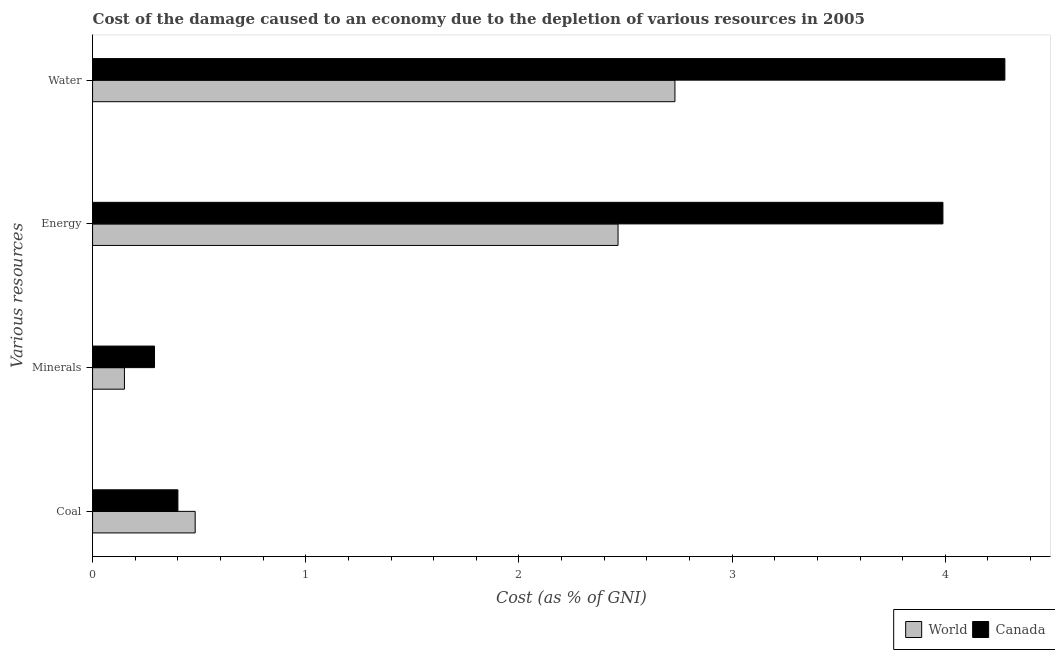How many groups of bars are there?
Keep it short and to the point. 4. Are the number of bars per tick equal to the number of legend labels?
Give a very brief answer. Yes. How many bars are there on the 1st tick from the bottom?
Keep it short and to the point. 2. What is the label of the 3rd group of bars from the top?
Give a very brief answer. Minerals. What is the cost of damage due to depletion of coal in World?
Your answer should be compact. 0.48. Across all countries, what is the maximum cost of damage due to depletion of water?
Your response must be concise. 4.28. Across all countries, what is the minimum cost of damage due to depletion of coal?
Ensure brevity in your answer.  0.4. What is the total cost of damage due to depletion of coal in the graph?
Keep it short and to the point. 0.88. What is the difference between the cost of damage due to depletion of water in Canada and that in World?
Make the answer very short. 1.55. What is the difference between the cost of damage due to depletion of coal in Canada and the cost of damage due to depletion of water in World?
Ensure brevity in your answer.  -2.33. What is the average cost of damage due to depletion of coal per country?
Offer a very short reply. 0.44. What is the difference between the cost of damage due to depletion of water and cost of damage due to depletion of coal in Canada?
Offer a very short reply. 3.88. What is the ratio of the cost of damage due to depletion of coal in Canada to that in World?
Make the answer very short. 0.83. Is the cost of damage due to depletion of coal in Canada less than that in World?
Provide a short and direct response. Yes. What is the difference between the highest and the second highest cost of damage due to depletion of minerals?
Provide a succinct answer. 0.14. What is the difference between the highest and the lowest cost of damage due to depletion of energy?
Ensure brevity in your answer.  1.52. Is it the case that in every country, the sum of the cost of damage due to depletion of energy and cost of damage due to depletion of minerals is greater than the sum of cost of damage due to depletion of water and cost of damage due to depletion of coal?
Keep it short and to the point. No. What does the 1st bar from the top in Energy represents?
Offer a terse response. Canada. What does the 2nd bar from the bottom in Energy represents?
Offer a very short reply. Canada. Is it the case that in every country, the sum of the cost of damage due to depletion of coal and cost of damage due to depletion of minerals is greater than the cost of damage due to depletion of energy?
Give a very brief answer. No. How many bars are there?
Keep it short and to the point. 8. How many countries are there in the graph?
Provide a succinct answer. 2. What is the difference between two consecutive major ticks on the X-axis?
Your response must be concise. 1. Where does the legend appear in the graph?
Your answer should be very brief. Bottom right. What is the title of the graph?
Offer a terse response. Cost of the damage caused to an economy due to the depletion of various resources in 2005 . What is the label or title of the X-axis?
Your answer should be very brief. Cost (as % of GNI). What is the label or title of the Y-axis?
Ensure brevity in your answer.  Various resources. What is the Cost (as % of GNI) of World in Coal?
Your answer should be compact. 0.48. What is the Cost (as % of GNI) in Canada in Coal?
Keep it short and to the point. 0.4. What is the Cost (as % of GNI) in World in Minerals?
Give a very brief answer. 0.15. What is the Cost (as % of GNI) in Canada in Minerals?
Offer a terse response. 0.29. What is the Cost (as % of GNI) in World in Energy?
Make the answer very short. 2.46. What is the Cost (as % of GNI) in Canada in Energy?
Your answer should be very brief. 3.99. What is the Cost (as % of GNI) in World in Water?
Keep it short and to the point. 2.73. What is the Cost (as % of GNI) in Canada in Water?
Your answer should be very brief. 4.28. Across all Various resources, what is the maximum Cost (as % of GNI) of World?
Ensure brevity in your answer.  2.73. Across all Various resources, what is the maximum Cost (as % of GNI) in Canada?
Your answer should be very brief. 4.28. Across all Various resources, what is the minimum Cost (as % of GNI) in World?
Provide a succinct answer. 0.15. Across all Various resources, what is the minimum Cost (as % of GNI) of Canada?
Make the answer very short. 0.29. What is the total Cost (as % of GNI) in World in the graph?
Give a very brief answer. 5.83. What is the total Cost (as % of GNI) of Canada in the graph?
Your answer should be very brief. 8.96. What is the difference between the Cost (as % of GNI) of World in Coal and that in Minerals?
Your response must be concise. 0.33. What is the difference between the Cost (as % of GNI) of Canada in Coal and that in Minerals?
Offer a terse response. 0.11. What is the difference between the Cost (as % of GNI) in World in Coal and that in Energy?
Provide a succinct answer. -1.98. What is the difference between the Cost (as % of GNI) of Canada in Coal and that in Energy?
Your answer should be compact. -3.59. What is the difference between the Cost (as % of GNI) in World in Coal and that in Water?
Provide a succinct answer. -2.25. What is the difference between the Cost (as % of GNI) in Canada in Coal and that in Water?
Ensure brevity in your answer.  -3.88. What is the difference between the Cost (as % of GNI) of World in Minerals and that in Energy?
Provide a short and direct response. -2.32. What is the difference between the Cost (as % of GNI) of Canada in Minerals and that in Energy?
Your answer should be compact. -3.7. What is the difference between the Cost (as % of GNI) in World in Minerals and that in Water?
Offer a very short reply. -2.58. What is the difference between the Cost (as % of GNI) of Canada in Minerals and that in Water?
Provide a short and direct response. -3.99. What is the difference between the Cost (as % of GNI) in World in Energy and that in Water?
Offer a terse response. -0.27. What is the difference between the Cost (as % of GNI) in Canada in Energy and that in Water?
Your response must be concise. -0.29. What is the difference between the Cost (as % of GNI) in World in Coal and the Cost (as % of GNI) in Canada in Minerals?
Keep it short and to the point. 0.19. What is the difference between the Cost (as % of GNI) of World in Coal and the Cost (as % of GNI) of Canada in Energy?
Your answer should be compact. -3.51. What is the difference between the Cost (as % of GNI) in World in Coal and the Cost (as % of GNI) in Canada in Water?
Ensure brevity in your answer.  -3.8. What is the difference between the Cost (as % of GNI) in World in Minerals and the Cost (as % of GNI) in Canada in Energy?
Your answer should be very brief. -3.84. What is the difference between the Cost (as % of GNI) in World in Minerals and the Cost (as % of GNI) in Canada in Water?
Provide a short and direct response. -4.13. What is the difference between the Cost (as % of GNI) in World in Energy and the Cost (as % of GNI) in Canada in Water?
Provide a succinct answer. -1.81. What is the average Cost (as % of GNI) in World per Various resources?
Offer a terse response. 1.46. What is the average Cost (as % of GNI) in Canada per Various resources?
Provide a short and direct response. 2.24. What is the difference between the Cost (as % of GNI) in World and Cost (as % of GNI) in Canada in Coal?
Offer a very short reply. 0.08. What is the difference between the Cost (as % of GNI) of World and Cost (as % of GNI) of Canada in Minerals?
Keep it short and to the point. -0.14. What is the difference between the Cost (as % of GNI) of World and Cost (as % of GNI) of Canada in Energy?
Make the answer very short. -1.52. What is the difference between the Cost (as % of GNI) of World and Cost (as % of GNI) of Canada in Water?
Ensure brevity in your answer.  -1.55. What is the ratio of the Cost (as % of GNI) of World in Coal to that in Minerals?
Keep it short and to the point. 3.22. What is the ratio of the Cost (as % of GNI) in Canada in Coal to that in Minerals?
Make the answer very short. 1.38. What is the ratio of the Cost (as % of GNI) of World in Coal to that in Energy?
Ensure brevity in your answer.  0.2. What is the ratio of the Cost (as % of GNI) of Canada in Coal to that in Energy?
Give a very brief answer. 0.1. What is the ratio of the Cost (as % of GNI) in World in Coal to that in Water?
Ensure brevity in your answer.  0.18. What is the ratio of the Cost (as % of GNI) in Canada in Coal to that in Water?
Your answer should be compact. 0.09. What is the ratio of the Cost (as % of GNI) of World in Minerals to that in Energy?
Your response must be concise. 0.06. What is the ratio of the Cost (as % of GNI) of Canada in Minerals to that in Energy?
Give a very brief answer. 0.07. What is the ratio of the Cost (as % of GNI) in World in Minerals to that in Water?
Offer a terse response. 0.05. What is the ratio of the Cost (as % of GNI) in Canada in Minerals to that in Water?
Provide a succinct answer. 0.07. What is the ratio of the Cost (as % of GNI) in World in Energy to that in Water?
Your answer should be compact. 0.9. What is the ratio of the Cost (as % of GNI) in Canada in Energy to that in Water?
Keep it short and to the point. 0.93. What is the difference between the highest and the second highest Cost (as % of GNI) in World?
Provide a short and direct response. 0.27. What is the difference between the highest and the second highest Cost (as % of GNI) in Canada?
Your answer should be very brief. 0.29. What is the difference between the highest and the lowest Cost (as % of GNI) in World?
Provide a succinct answer. 2.58. What is the difference between the highest and the lowest Cost (as % of GNI) in Canada?
Give a very brief answer. 3.99. 